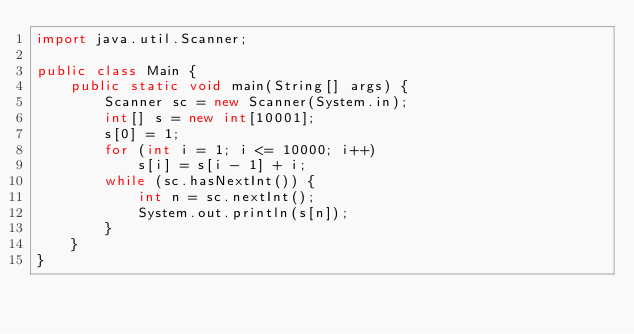Convert code to text. <code><loc_0><loc_0><loc_500><loc_500><_Java_>import java.util.Scanner;

public class Main {
	public static void main(String[] args) {
		Scanner sc = new Scanner(System.in);
		int[] s = new int[10001];
		s[0] = 1;
		for (int i = 1; i <= 10000; i++)
			s[i] = s[i - 1] + i;
		while (sc.hasNextInt()) {
			int n = sc.nextInt();
			System.out.println(s[n]);
		}
	}
}</code> 